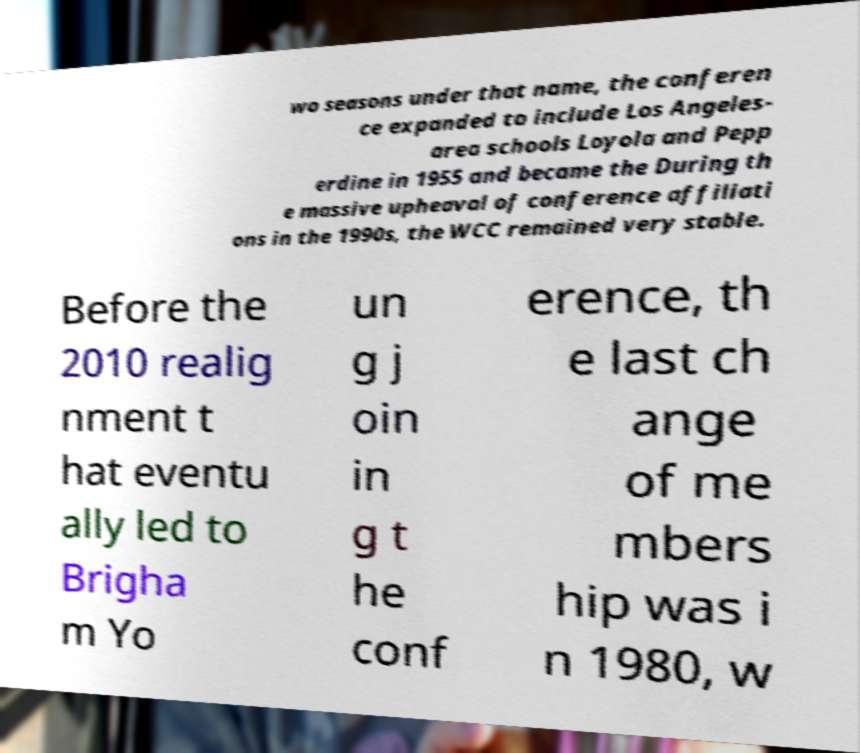What messages or text are displayed in this image? I need them in a readable, typed format. wo seasons under that name, the conferen ce expanded to include Los Angeles- area schools Loyola and Pepp erdine in 1955 and became the During th e massive upheaval of conference affiliati ons in the 1990s, the WCC remained very stable. Before the 2010 realig nment t hat eventu ally led to Brigha m Yo un g j oin in g t he conf erence, th e last ch ange of me mbers hip was i n 1980, w 